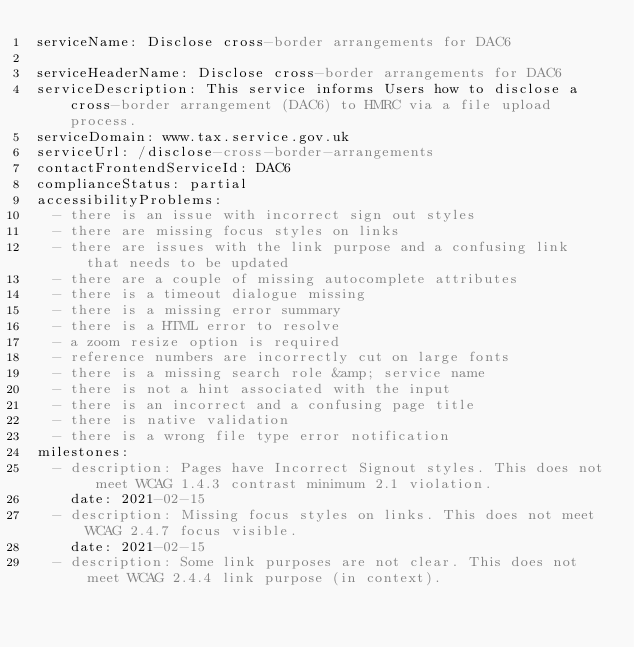<code> <loc_0><loc_0><loc_500><loc_500><_YAML_>serviceName: Disclose cross-border arrangements for DAC6

serviceHeaderName: Disclose cross-border arrangements for DAC6
serviceDescription: This service informs Users how to disclose a cross-border arrangement (DAC6) to HMRC via a file upload process.
serviceDomain: www.tax.service.gov.uk
serviceUrl: /disclose-cross-border-arrangements
contactFrontendServiceId: DAC6
complianceStatus: partial
accessibilityProblems:
  - there is an issue with incorrect sign out styles
  - there are missing focus styles on links
  - there are issues with the link purpose and a confusing link that needs to be updated
  - there are a couple of missing autocomplete attributes
  - there is a timeout dialogue missing
  - there is a missing error summary
  - there is a HTML error to resolve
  - a zoom resize option is required
  - reference numbers are incorrectly cut on large fonts
  - there is a missing search role &amp; service name
  - there is not a hint associated with the input
  - there is an incorrect and a confusing page title
  - there is native validation
  - there is a wrong file type error notification
milestones:
  - description: Pages have Incorrect Signout styles. This does not meet WCAG 1.4.3 contrast minimum 2.1 violation.
    date: 2021-02-15
  - description: Missing focus styles on links. This does not meet WCAG 2.4.7 focus visible.
    date: 2021-02-15
  - description: Some link purposes are not clear. This does not meet WCAG 2.4.4 link purpose (in context).</code> 